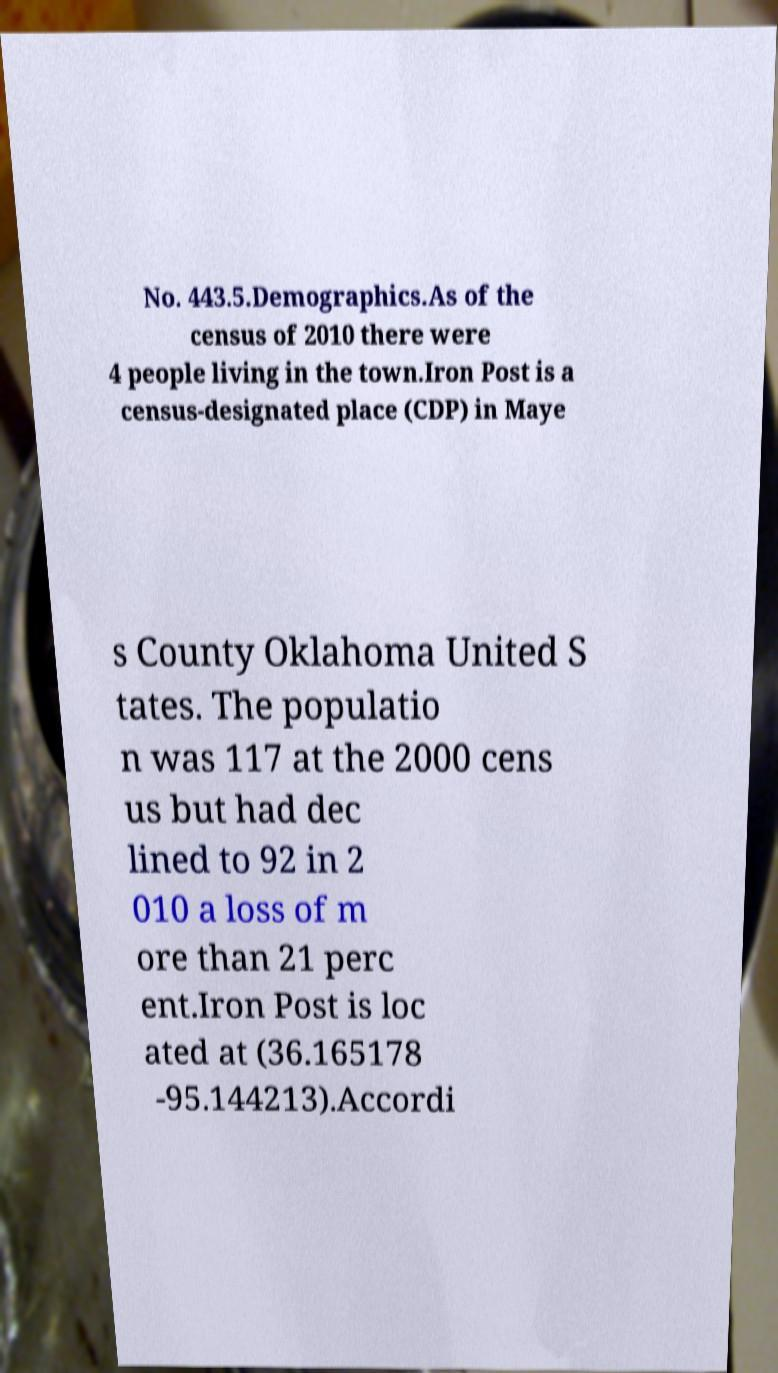For documentation purposes, I need the text within this image transcribed. Could you provide that? No. 443.5.Demographics.As of the census of 2010 there were 4 people living in the town.Iron Post is a census-designated place (CDP) in Maye s County Oklahoma United S tates. The populatio n was 117 at the 2000 cens us but had dec lined to 92 in 2 010 a loss of m ore than 21 perc ent.Iron Post is loc ated at (36.165178 -95.144213).Accordi 